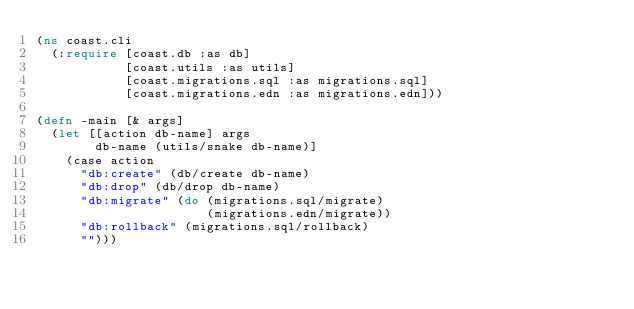<code> <loc_0><loc_0><loc_500><loc_500><_Clojure_>(ns coast.cli
  (:require [coast.db :as db]
            [coast.utils :as utils]
            [coast.migrations.sql :as migrations.sql]
            [coast.migrations.edn :as migrations.edn]))

(defn -main [& args]
  (let [[action db-name] args
        db-name (utils/snake db-name)]
    (case action
      "db:create" (db/create db-name)
      "db:drop" (db/drop db-name)
      "db:migrate" (do (migrations.sql/migrate)
                       (migrations.edn/migrate))
      "db:rollback" (migrations.sql/rollback)
      "")))
</code> 